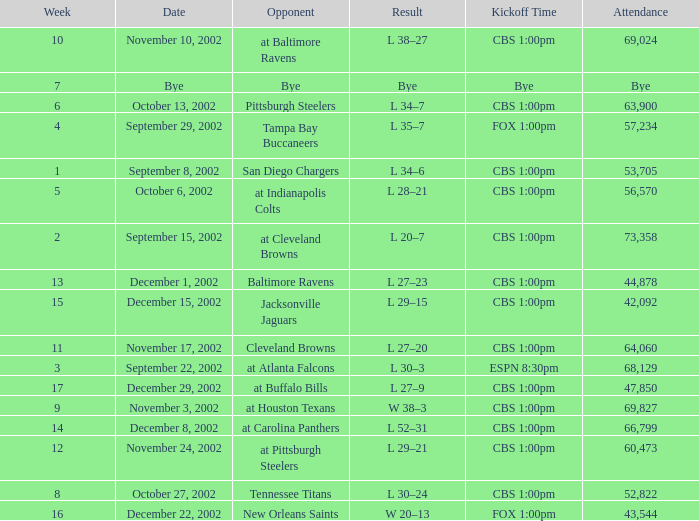What week number was the kickoff time cbs 1:00pm, with 60,473 people in attendance? 1.0. 